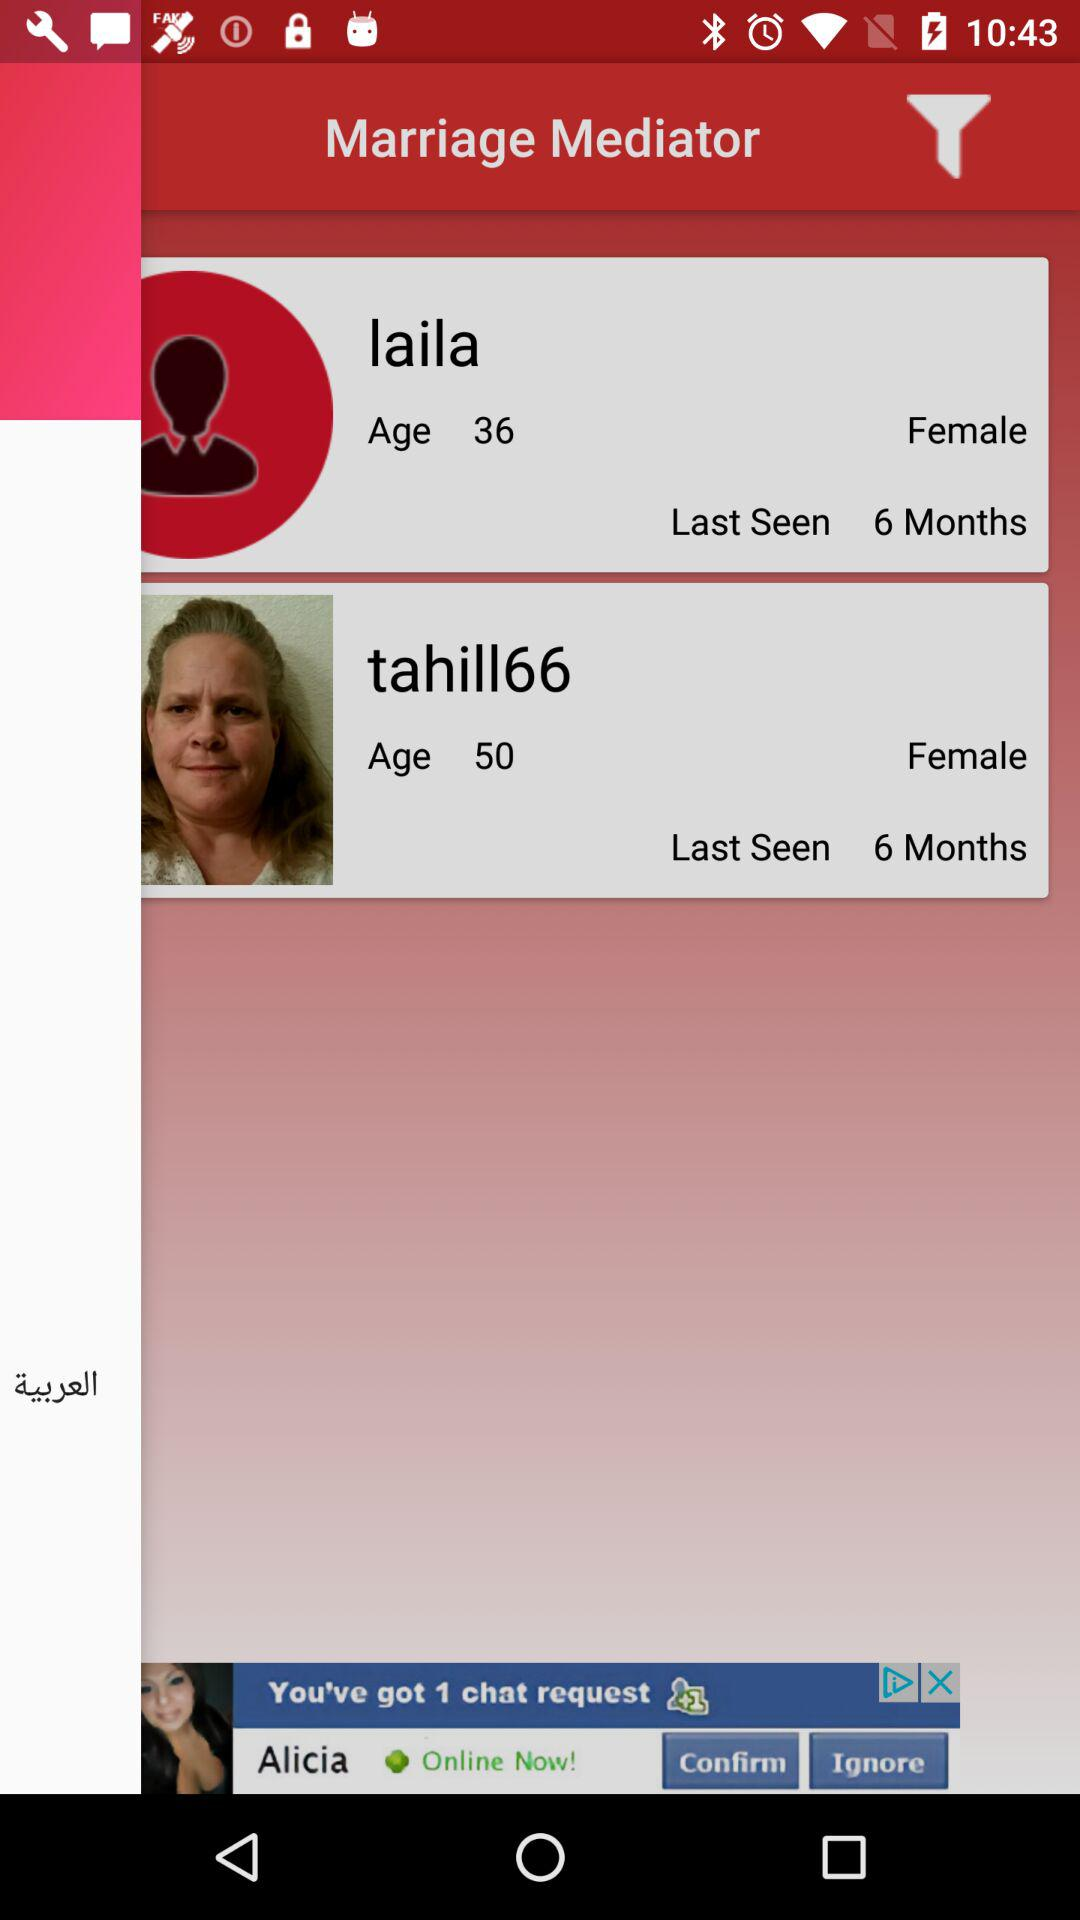What is the age of "laila"? The age of "laila" is 36. 